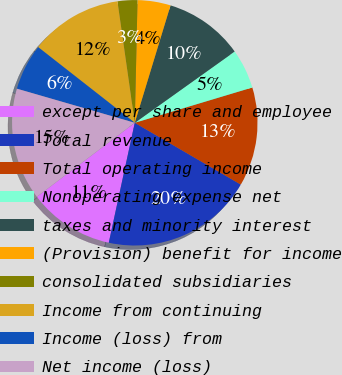Convert chart to OTSL. <chart><loc_0><loc_0><loc_500><loc_500><pie_chart><fcel>except per share and employee<fcel>Total revenue<fcel>Total operating income<fcel>Nonoperating expense net<fcel>taxes and minority interest<fcel>(Provision) benefit for income<fcel>consolidated subsidiaries<fcel>Income from continuing<fcel>Income (loss) from<fcel>Net income (loss)<nl><fcel>11.3%<fcel>20.0%<fcel>13.04%<fcel>5.22%<fcel>10.43%<fcel>4.35%<fcel>2.61%<fcel>12.17%<fcel>6.09%<fcel>14.78%<nl></chart> 